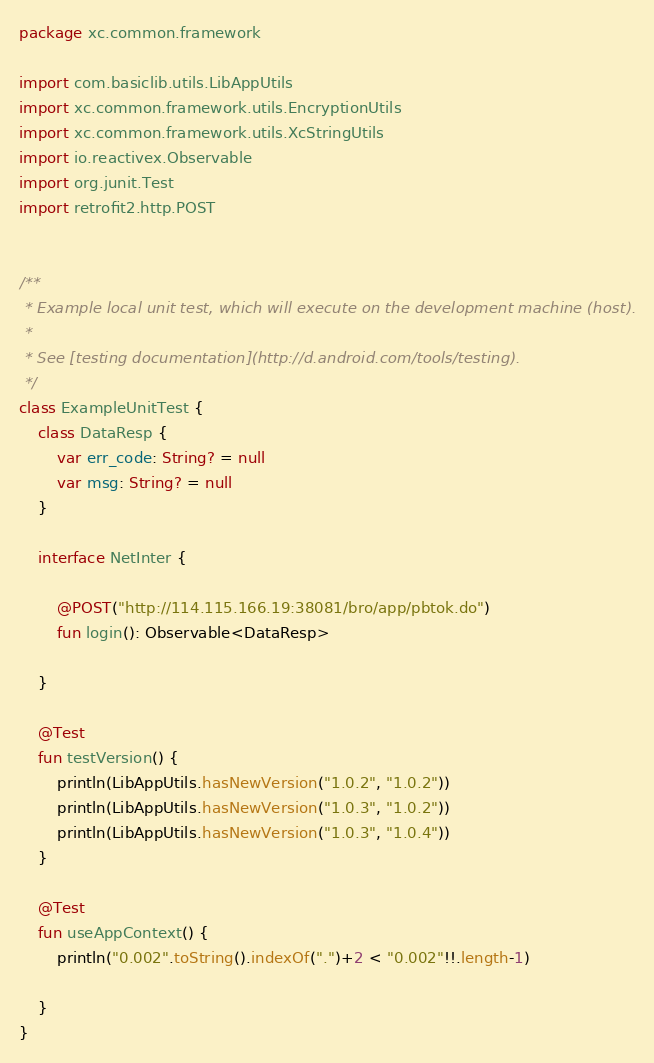Convert code to text. <code><loc_0><loc_0><loc_500><loc_500><_Kotlin_>package xc.common.framework

import com.basiclib.utils.LibAppUtils
import xc.common.framework.utils.EncryptionUtils
import xc.common.framework.utils.XcStringUtils
import io.reactivex.Observable
import org.junit.Test
import retrofit2.http.POST


/**
 * Example local unit test, which will execute on the development machine (host).
 *
 * See [testing documentation](http://d.android.com/tools/testing).
 */
class ExampleUnitTest {
    class DataResp {
        var err_code: String? = null
        var msg: String? = null
    }

    interface NetInter {

        @POST("http://114.115.166.19:38081/bro/app/pbtok.do")
        fun login(): Observable<DataResp>

    }

    @Test
    fun testVersion() {
        println(LibAppUtils.hasNewVersion("1.0.2", "1.0.2"))
        println(LibAppUtils.hasNewVersion("1.0.3", "1.0.2"))
        println(LibAppUtils.hasNewVersion("1.0.3", "1.0.4"))
    }

    @Test
    fun useAppContext() {
        println("0.002".toString().indexOf(".")+2 < "0.002"!!.length-1)

    }
}
</code> 